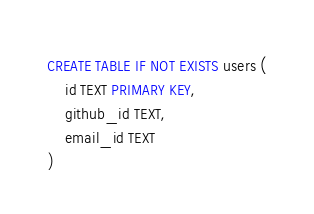Convert code to text. <code><loc_0><loc_0><loc_500><loc_500><_SQL_>CREATE TABLE IF NOT EXISTS users (
    id TEXT PRIMARY KEY,
    github_id TEXT,
    email_id TEXT
)
</code> 